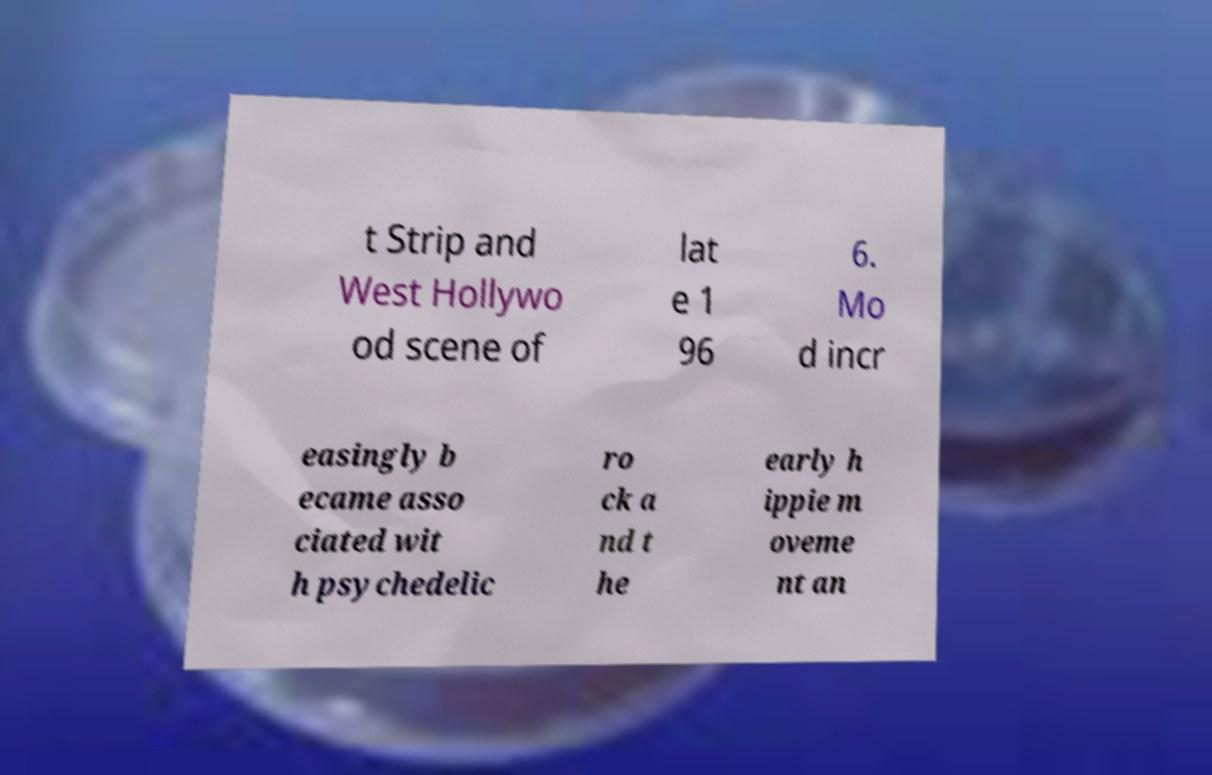Please identify and transcribe the text found in this image. t Strip and West Hollywo od scene of lat e 1 96 6. Mo d incr easingly b ecame asso ciated wit h psychedelic ro ck a nd t he early h ippie m oveme nt an 